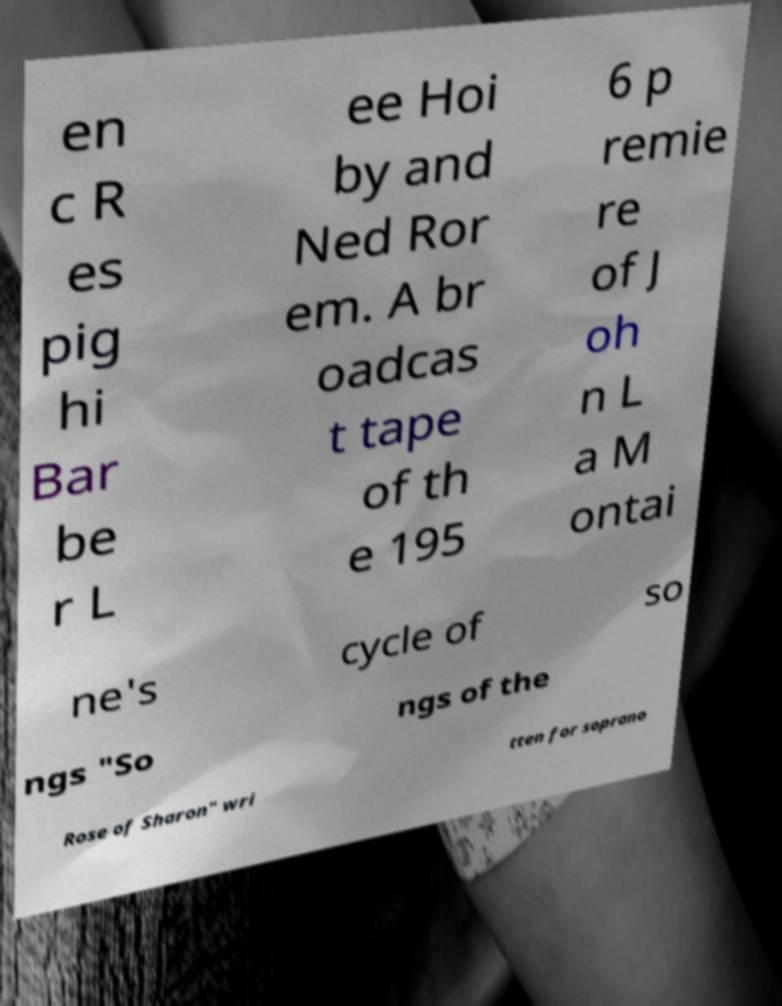I need the written content from this picture converted into text. Can you do that? en c R es pig hi Bar be r L ee Hoi by and Ned Ror em. A br oadcas t tape of th e 195 6 p remie re of J oh n L a M ontai ne's cycle of so ngs "So ngs of the Rose of Sharon" wri tten for soprano 